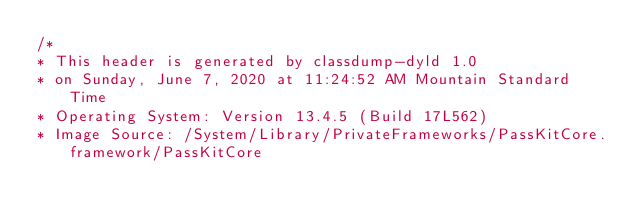<code> <loc_0><loc_0><loc_500><loc_500><_C_>/*
* This header is generated by classdump-dyld 1.0
* on Sunday, June 7, 2020 at 11:24:52 AM Mountain Standard Time
* Operating System: Version 13.4.5 (Build 17L562)
* Image Source: /System/Library/PrivateFrameworks/PassKitCore.framework/PassKitCore</code> 